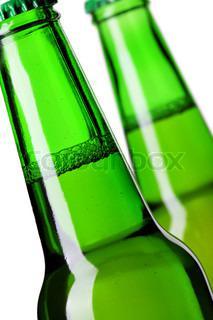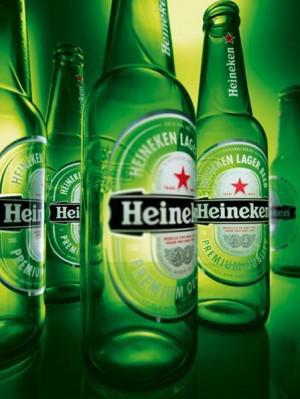The first image is the image on the left, the second image is the image on the right. Analyze the images presented: Is the assertion "An image contains exactly two bottles displayed vertically." valid? Answer yes or no. No. The first image is the image on the left, the second image is the image on the right. Considering the images on both sides, is "A single green beer bottle is shown in one image." valid? Answer yes or no. No. 